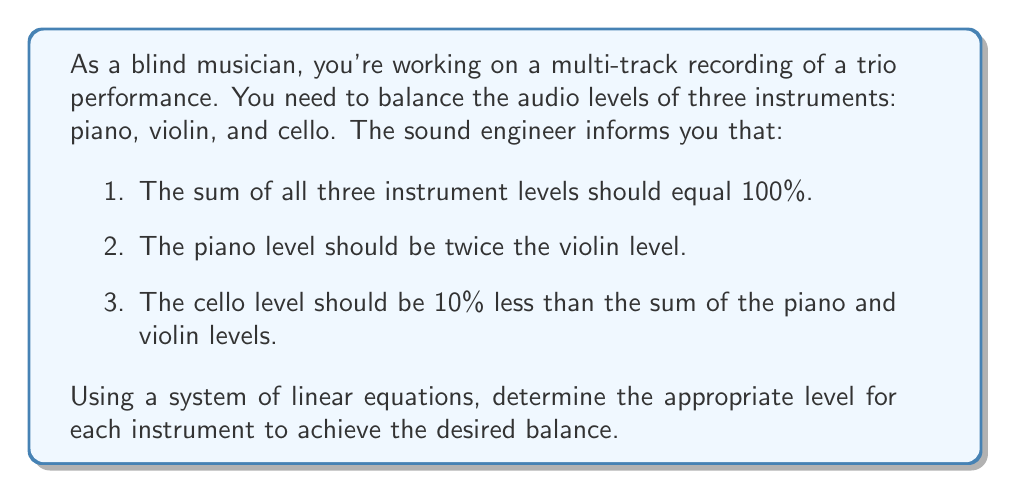Could you help me with this problem? Let's approach this problem step-by-step using a system of linear equations:

1. Define variables:
   Let $p$ = piano level
   Let $v$ = violin level
   Let $c$ = cello level

2. Set up the system of equations based on the given information:

   Equation 1: $p + v + c = 100$ (sum of all levels equals 100%)
   Equation 2: $p = 2v$ (piano level is twice the violin level)
   Equation 3: $c = 0.9(p + v)$ (cello level is 10% less than sum of piano and violin)

3. Substitute equation 2 into equation 1 and equation 3:

   $2v + v + c = 100$
   $c = 0.9(2v + v) = 2.7v$

4. Now we have:

   $3v + 2.7v = 100$
   $5.7v = 100$

5. Solve for $v$:

   $v = 100 / 5.7 \approx 17.54$

6. Calculate $p$ using equation 2:

   $p = 2v = 2 * 17.54 \approx 35.09$

7. Calculate $c$ using equation 3:

   $c = 0.9(p + v) = 0.9(35.09 + 17.54) \approx 47.37$

8. Verify that the sum equals 100%:

   $17.54 + 35.09 + 47.37 = 100$

Therefore, the balanced audio levels for each instrument are:
Piano: 35.09%
Violin: 17.54%
Cello: 47.37%
Answer: Piano: 35.09%
Violin: 17.54%
Cello: 47.37% 